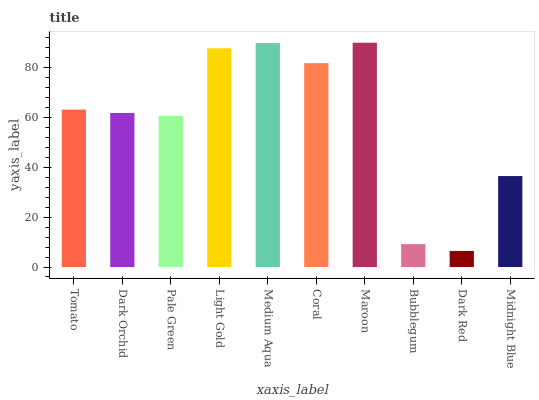Is Dark Red the minimum?
Answer yes or no. Yes. Is Maroon the maximum?
Answer yes or no. Yes. Is Dark Orchid the minimum?
Answer yes or no. No. Is Dark Orchid the maximum?
Answer yes or no. No. Is Tomato greater than Dark Orchid?
Answer yes or no. Yes. Is Dark Orchid less than Tomato?
Answer yes or no. Yes. Is Dark Orchid greater than Tomato?
Answer yes or no. No. Is Tomato less than Dark Orchid?
Answer yes or no. No. Is Tomato the high median?
Answer yes or no. Yes. Is Dark Orchid the low median?
Answer yes or no. Yes. Is Midnight Blue the high median?
Answer yes or no. No. Is Pale Green the low median?
Answer yes or no. No. 